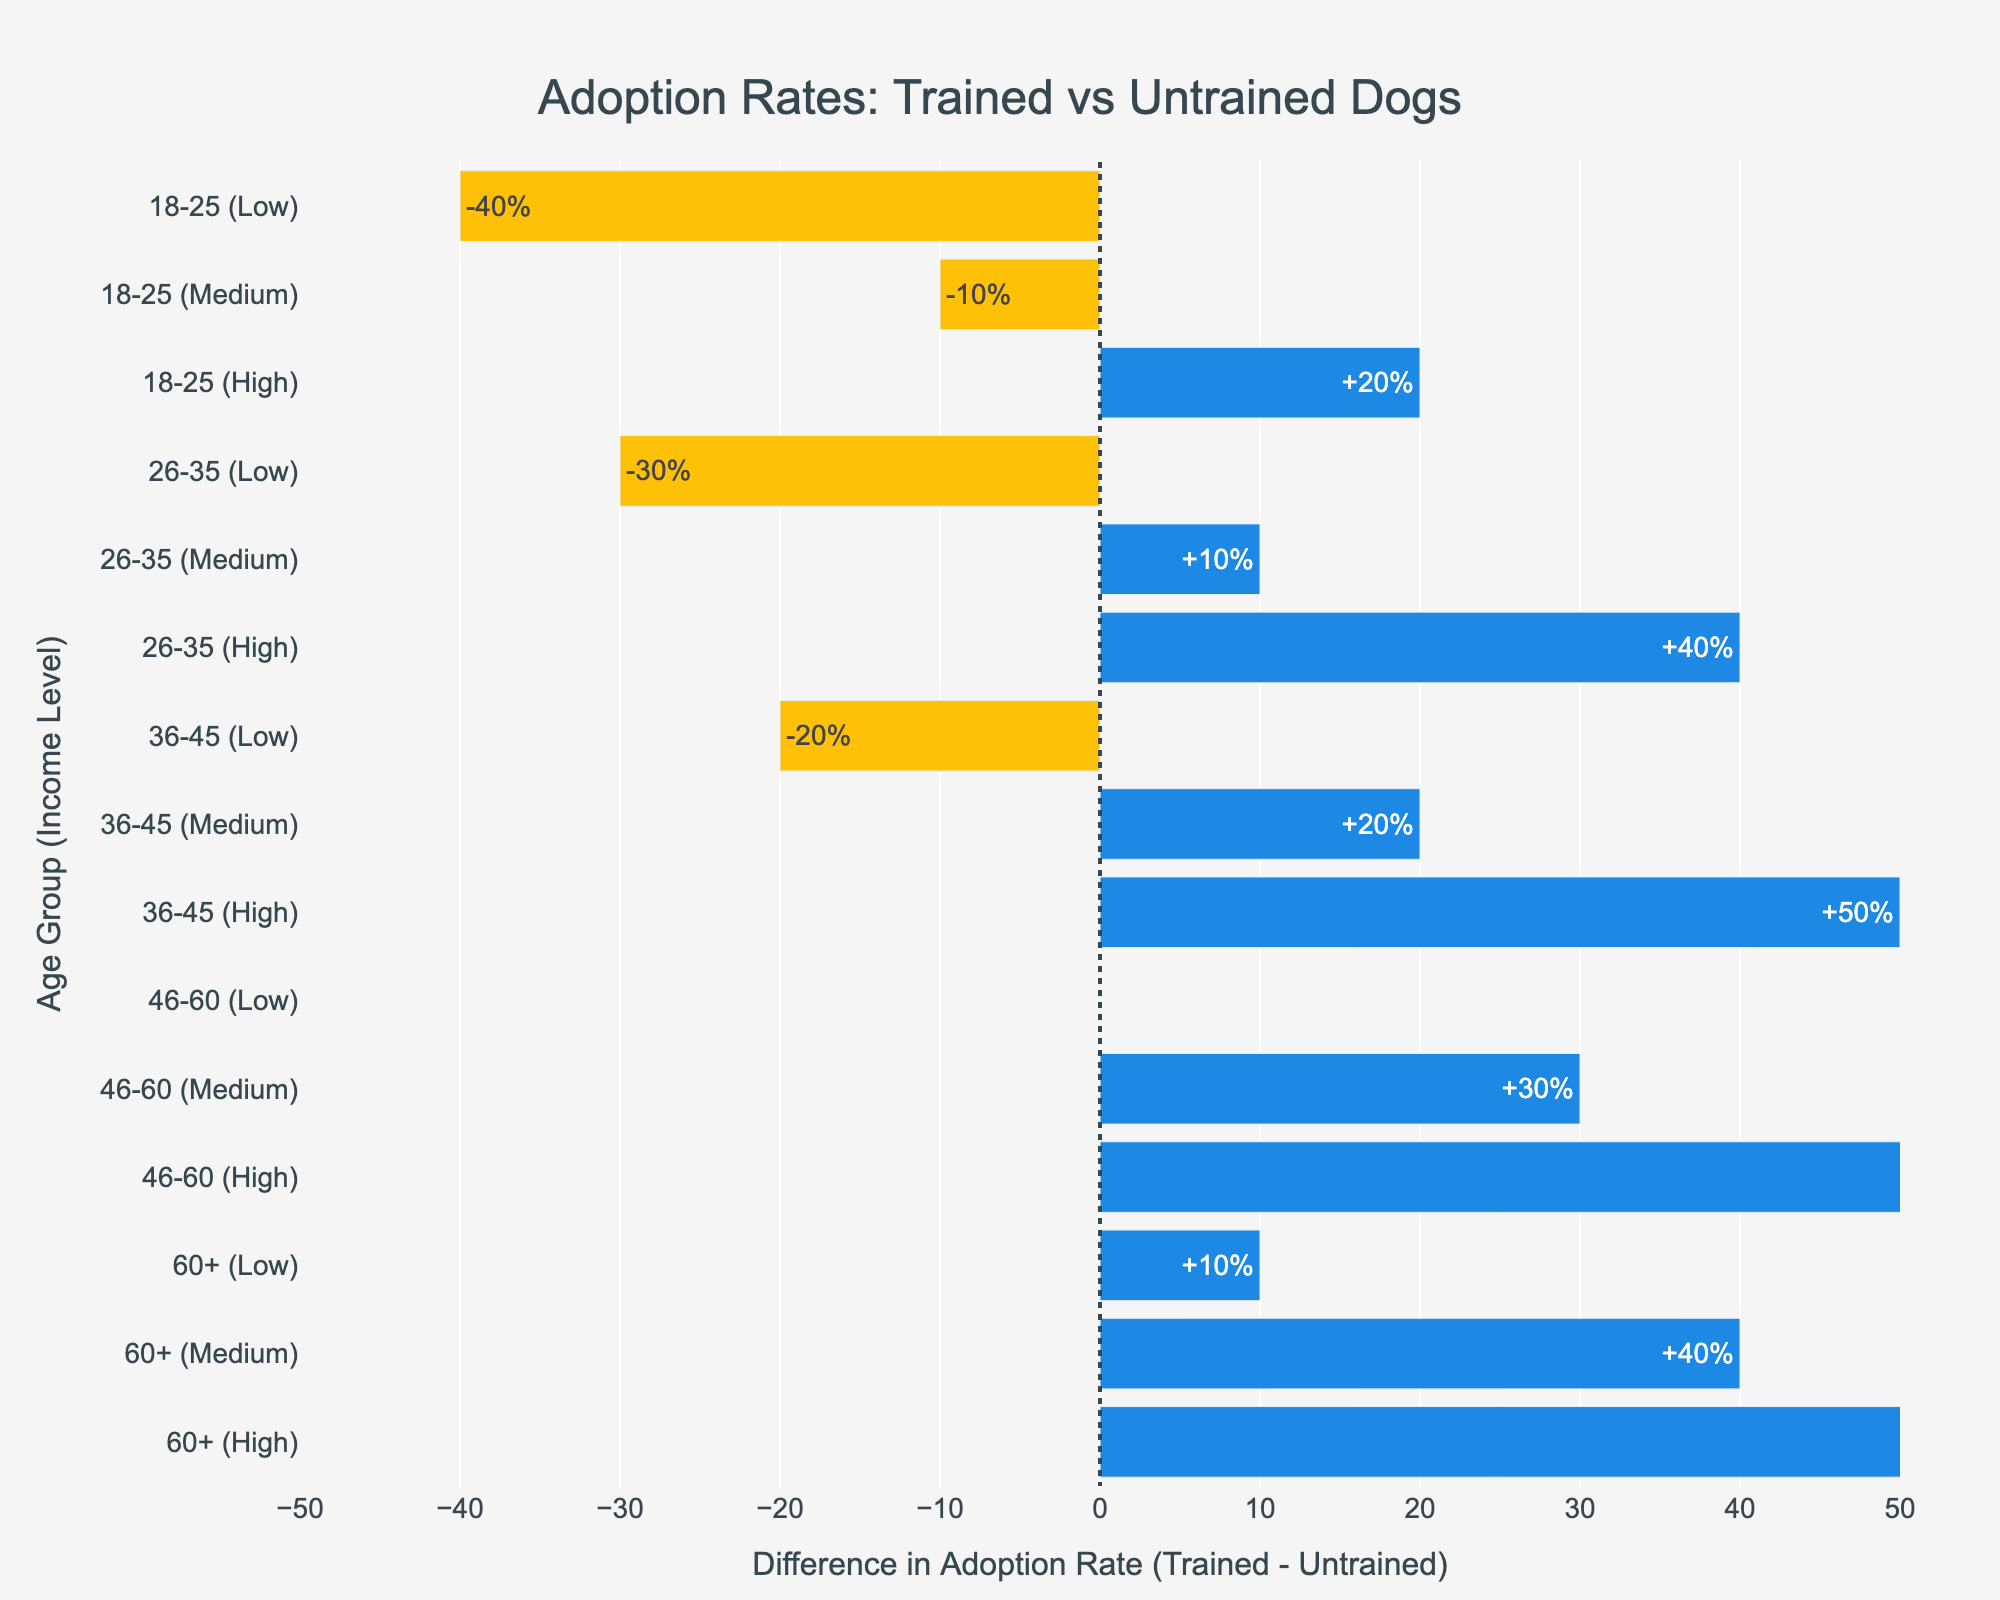Which age group with a medium income level shows a higher adoption rate of trained dogs? Look for the bar representing the age group with a medium income level and observe its position relative to the x-axis. The largest positive value indicates the higher adoption rate of trained dogs.
Answer: 60+ Which demographic group shows the largest difference in favor of trained dog adoptions? Identify the bar stretching farthest to the right (positive side) on the x-axis, which indicates the largest adoption difference favoring trained dogs.
Answer: 60+ (High) How does the adoption difference for the 18-25 age group with low income compare to that of the 26-35 age group with medium income? Locate and compare the bar heights for both groups. Note that the 18-25 group with low income has a lower adoption difference (left) than the 26-35 group with medium income (right).
Answer: 18-25 group (Low) has a lower adoption difference What is the trend in adoption differences for trained dogs among high-income levels across different age groups? Examine the bars for high-income levels across age groups and identify the direction and magnitude of the differences. As the age group increases, the positive difference in trained dog adoptions increases.
Answer: Increasing positive difference with age Which demographic group has the smallest difference between trained and untrained dog adoptions? Look for the bar closest to the x=0 line, indicating the smallest difference.
Answer: 46-60 (Low) Is there a demographic group where untrained dogs have higher adoption rates than trained dogs? Identify bars on the negative side of the x-axis. These bars indicate a higher adoption rate of untrained dogs.
Answer: 18-25 (Low) How does the adoption difference for trained dogs in the 36-45 age group with a low income compare to that of the same age group with a high income? Compare the positions of the two bars for the 36-45 age group with low and high incomes. The high-income group shows a more positive difference (right) than the low-income group (left).
Answer: Higher for the high-income group Which age group shows the most significant change in adoption difference from low to high income levels? Identify the groups where the differences in adoption rates are largest between low and high incomes by examining bars under the same age group. For instance, 60+ age group shows the most substantial change from low (left) to high (right).
Answer: 60+ What is the median difference in adoption rates for the 26-35 age group across all income levels? Arrange the differences for this age group: 35 (Low), 55 (Medium), 70 (High). The median value is the one in the middle.
Answer: 55 How do the adoption differences for trained dogs in the 18-25 age group with medium income compare to the 46-60 age group with the same income? Compare the bars for both age groups within the medium income level. The 46-60 group shows a more positive difference (right) than the 18-25 group (left).
Answer: Higher in the 46-60 age group 